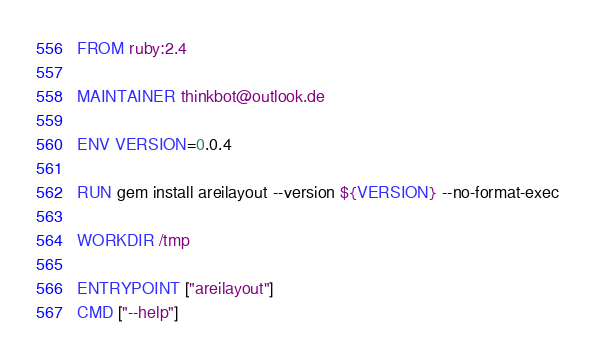<code> <loc_0><loc_0><loc_500><loc_500><_Dockerfile_>FROM ruby:2.4

MAINTAINER thinkbot@outlook.de

ENV VERSION=0.0.4

RUN gem install areilayout --version ${VERSION} --no-format-exec

WORKDIR /tmp

ENTRYPOINT ["areilayout"]
CMD ["--help"]
</code> 